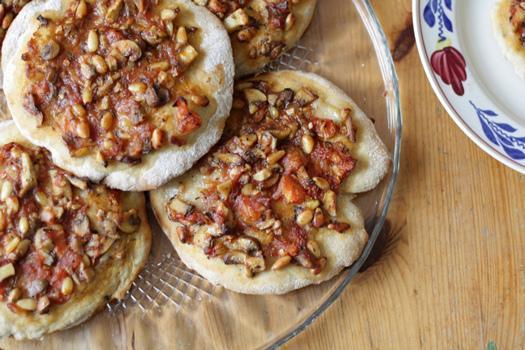How many pizzas are there?
Give a very brief answer. 4. 